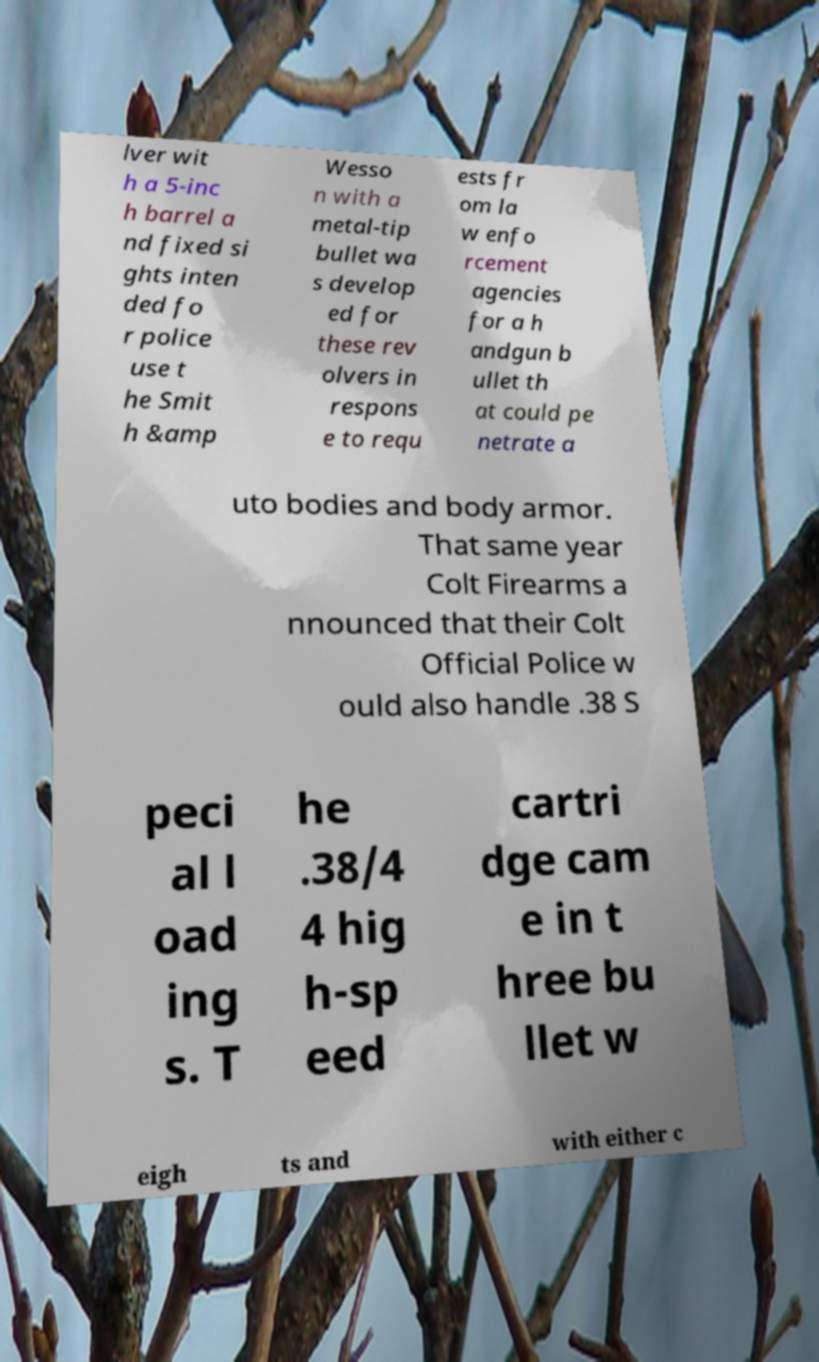Can you read and provide the text displayed in the image?This photo seems to have some interesting text. Can you extract and type it out for me? lver wit h a 5-inc h barrel a nd fixed si ghts inten ded fo r police use t he Smit h &amp Wesso n with a metal-tip bullet wa s develop ed for these rev olvers in respons e to requ ests fr om la w enfo rcement agencies for a h andgun b ullet th at could pe netrate a uto bodies and body armor. That same year Colt Firearms a nnounced that their Colt Official Police w ould also handle .38 S peci al l oad ing s. T he .38/4 4 hig h-sp eed cartri dge cam e in t hree bu llet w eigh ts and with either c 